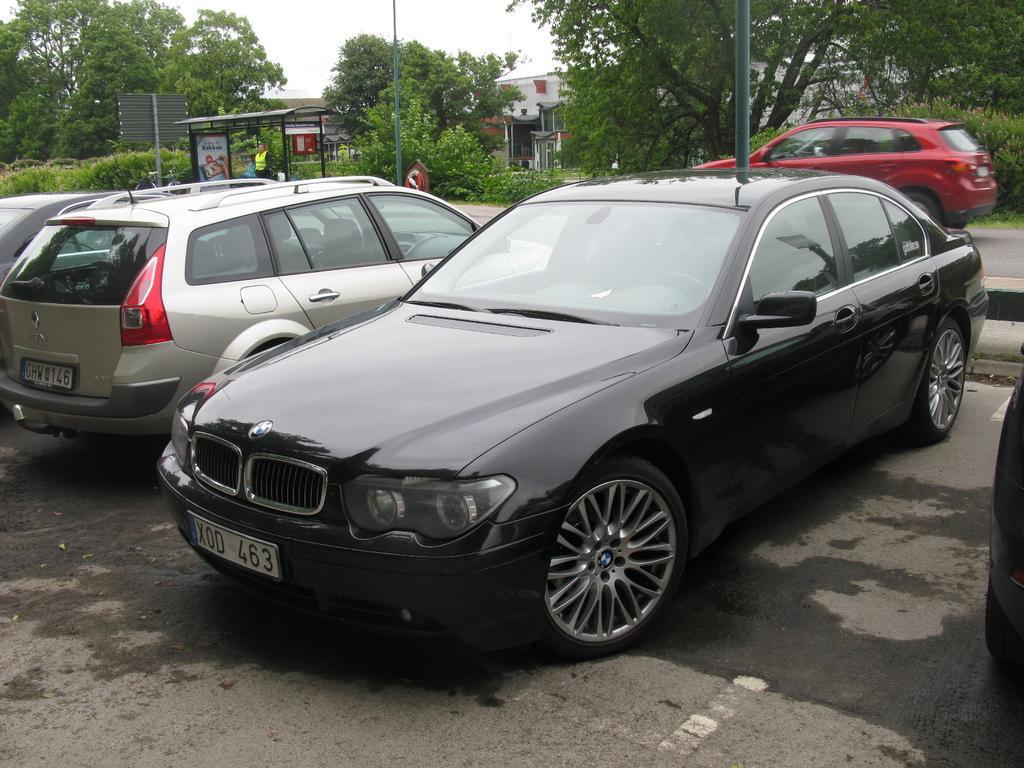Please provide a concise description of this image. In the foreground of the picture there are cars parked on the road and there is pole. In the center of the picture there are plants, bus stop, person, pole, dustbin and car on the road. In the background there are trees and buildings. 